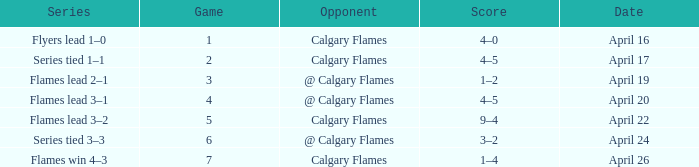Which Series has an Opponent of calgary flames, and a Score of 9–4? Flames lead 3–2. 